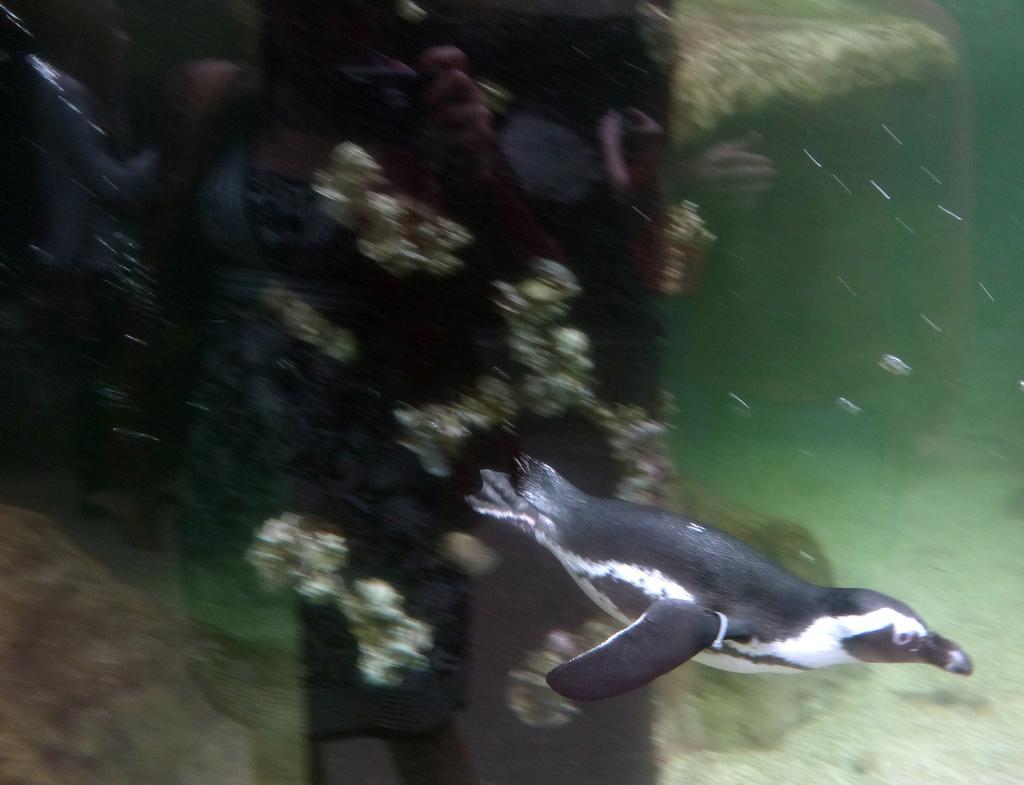Can you describe this image briefly? In this picture there is a seal in the water. At the back there are marine plants in the water. At the bottom there are pebbles. 